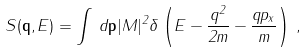<formula> <loc_0><loc_0><loc_500><loc_500>S ( { \mathbf q } , E ) = \int \, d { \mathbf p } | M | ^ { 2 } \delta \left ( E - \frac { q ^ { 2 } } { 2 m } - \frac { q p _ { x } } { m } \right ) \, ,</formula> 